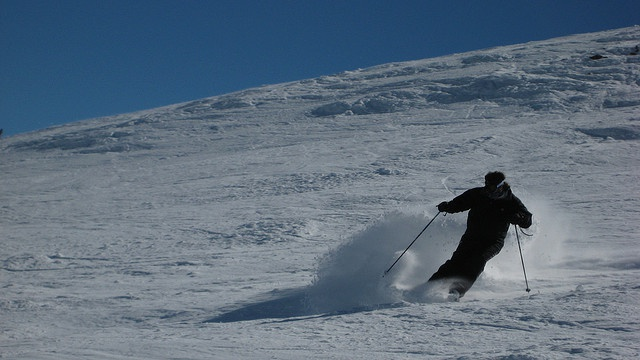Describe the objects in this image and their specific colors. I can see people in darkblue, black, gray, and darkgray tones in this image. 